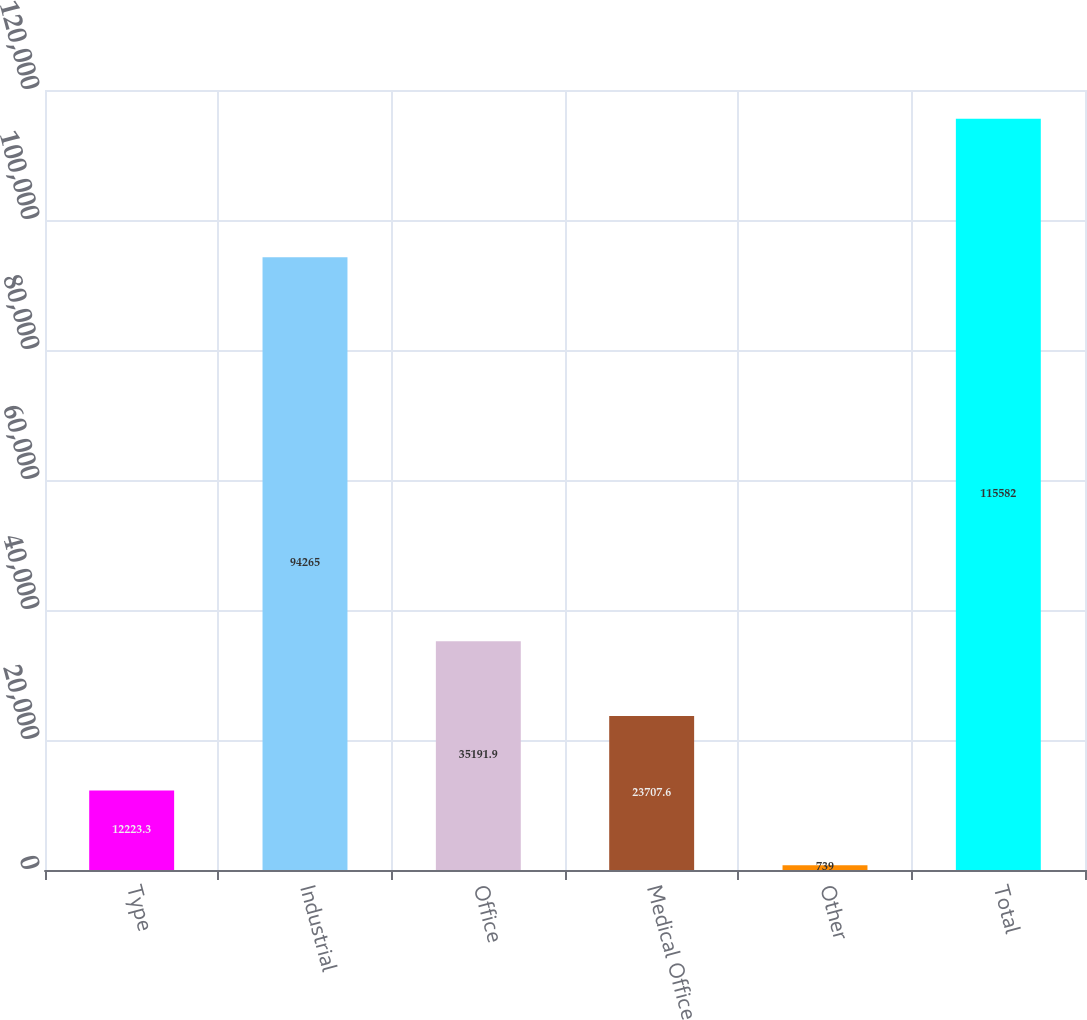Convert chart to OTSL. <chart><loc_0><loc_0><loc_500><loc_500><bar_chart><fcel>Type<fcel>Industrial<fcel>Office<fcel>Medical Office<fcel>Other<fcel>Total<nl><fcel>12223.3<fcel>94265<fcel>35191.9<fcel>23707.6<fcel>739<fcel>115582<nl></chart> 